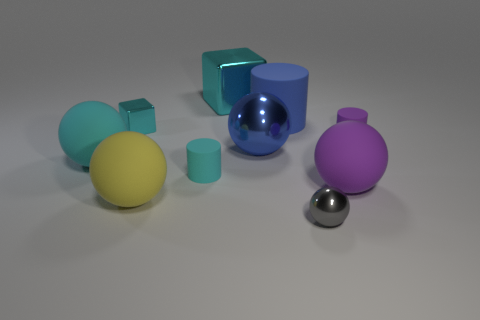The other blue object that is the same size as the blue matte object is what shape?
Give a very brief answer. Sphere. What is the color of the big ball that is the same material as the tiny cyan block?
Keep it short and to the point. Blue. Does the tiny gray object have the same shape as the blue thing on the right side of the blue metallic ball?
Keep it short and to the point. No. There is a cylinder that is the same color as the tiny cube; what material is it?
Your answer should be very brief. Rubber. There is a sphere that is the same size as the purple matte cylinder; what material is it?
Give a very brief answer. Metal. Are there any matte spheres of the same color as the big cube?
Give a very brief answer. Yes. What shape is the matte thing that is both behind the large yellow object and left of the tiny cyan rubber cylinder?
Give a very brief answer. Sphere. What number of objects are the same material as the small cube?
Provide a succinct answer. 3. Is the number of large rubber things that are behind the small cyan matte object less than the number of yellow matte things that are left of the large yellow rubber ball?
Offer a very short reply. No. There is a cyan block that is in front of the big matte thing that is behind the shiny block that is in front of the large cylinder; what is it made of?
Provide a succinct answer. Metal. 